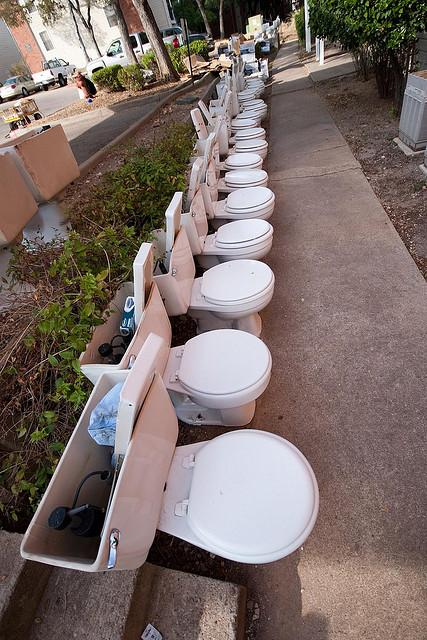What's happening with these toilets? Please explain your reasoning. displaying them. This is the most likely reason. that said, it could also be any of the other answers.it's impossible to tell from the image. 